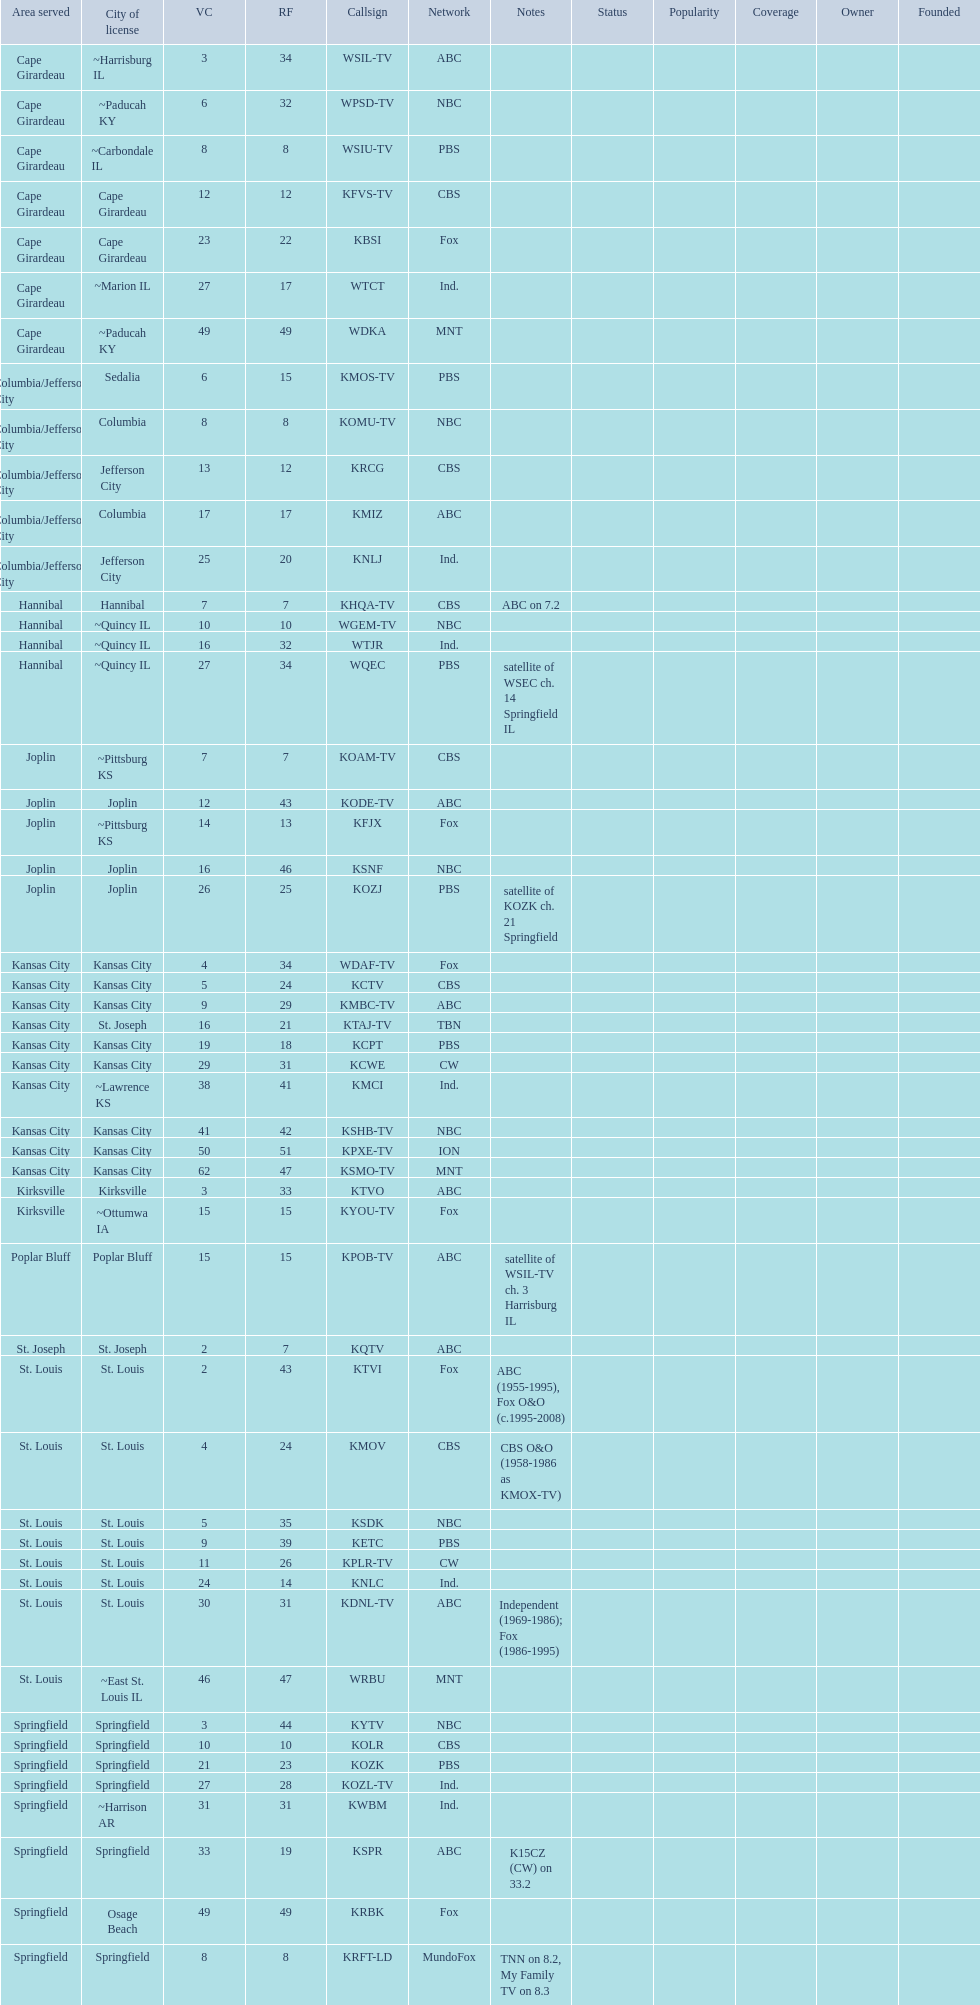What is the count of participants on the cbs network? 7. 